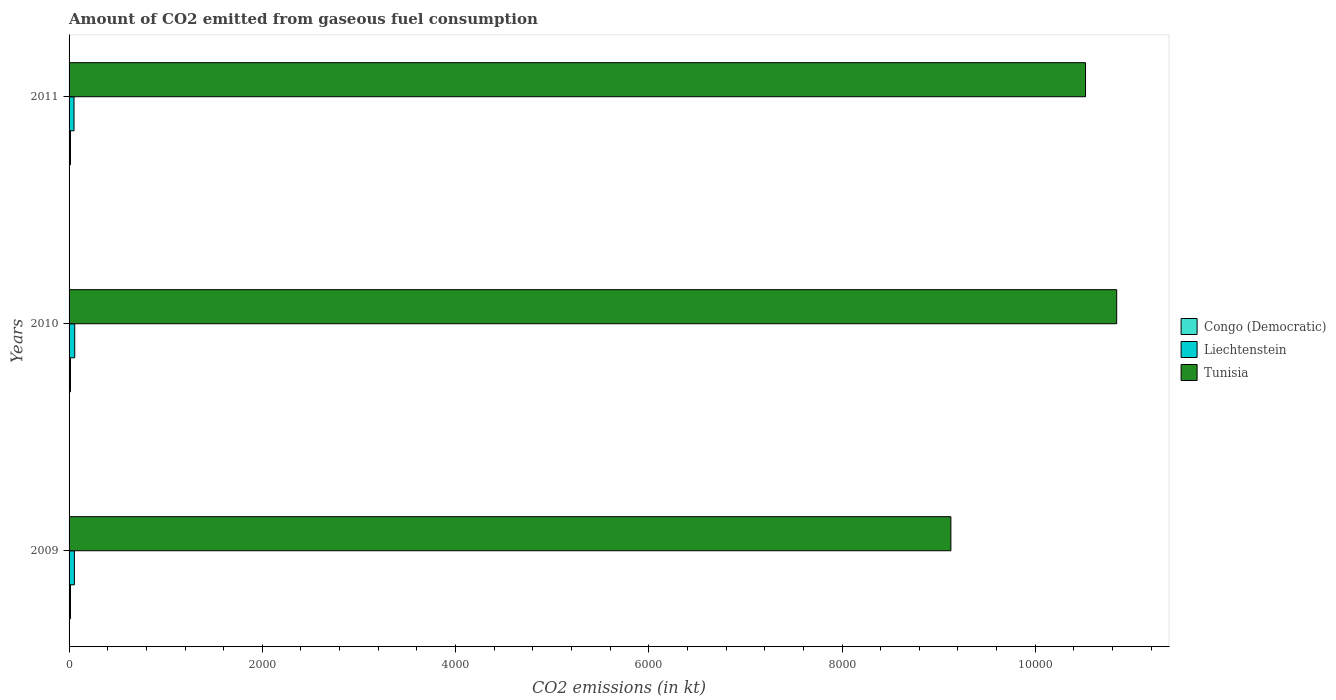Are the number of bars per tick equal to the number of legend labels?
Provide a succinct answer. Yes. How many bars are there on the 1st tick from the top?
Your answer should be compact. 3. What is the label of the 1st group of bars from the top?
Provide a succinct answer. 2011. What is the amount of CO2 emitted in Tunisia in 2010?
Keep it short and to the point. 1.08e+04. Across all years, what is the maximum amount of CO2 emitted in Tunisia?
Provide a short and direct response. 1.08e+04. Across all years, what is the minimum amount of CO2 emitted in Congo (Democratic)?
Make the answer very short. 14.67. In which year was the amount of CO2 emitted in Congo (Democratic) maximum?
Keep it short and to the point. 2009. In which year was the amount of CO2 emitted in Congo (Democratic) minimum?
Provide a succinct answer. 2009. What is the total amount of CO2 emitted in Liechtenstein in the graph?
Offer a very short reply. 165.01. What is the difference between the amount of CO2 emitted in Liechtenstein in 2009 and the amount of CO2 emitted in Congo (Democratic) in 2011?
Provide a short and direct response. 40.34. What is the average amount of CO2 emitted in Tunisia per year?
Your response must be concise. 1.02e+04. In the year 2010, what is the difference between the amount of CO2 emitted in Tunisia and amount of CO2 emitted in Liechtenstein?
Your response must be concise. 1.08e+04. What is the ratio of the amount of CO2 emitted in Liechtenstein in 2009 to that in 2011?
Keep it short and to the point. 1.07. Is the difference between the amount of CO2 emitted in Tunisia in 2009 and 2010 greater than the difference between the amount of CO2 emitted in Liechtenstein in 2009 and 2010?
Ensure brevity in your answer.  No. What is the difference between the highest and the second highest amount of CO2 emitted in Tunisia?
Your response must be concise. 322.7. Is the sum of the amount of CO2 emitted in Tunisia in 2009 and 2010 greater than the maximum amount of CO2 emitted in Congo (Democratic) across all years?
Offer a terse response. Yes. What does the 2nd bar from the top in 2010 represents?
Make the answer very short. Liechtenstein. What does the 1st bar from the bottom in 2010 represents?
Your answer should be compact. Congo (Democratic). Is it the case that in every year, the sum of the amount of CO2 emitted in Liechtenstein and amount of CO2 emitted in Congo (Democratic) is greater than the amount of CO2 emitted in Tunisia?
Ensure brevity in your answer.  No. How many bars are there?
Keep it short and to the point. 9. How many years are there in the graph?
Your answer should be very brief. 3. What is the difference between two consecutive major ticks on the X-axis?
Offer a terse response. 2000. Does the graph contain any zero values?
Make the answer very short. No. What is the title of the graph?
Give a very brief answer. Amount of CO2 emitted from gaseous fuel consumption. Does "Nicaragua" appear as one of the legend labels in the graph?
Make the answer very short. No. What is the label or title of the X-axis?
Provide a short and direct response. CO2 emissions (in kt). What is the label or title of the Y-axis?
Offer a very short reply. Years. What is the CO2 emissions (in kt) of Congo (Democratic) in 2009?
Offer a terse response. 14.67. What is the CO2 emissions (in kt) in Liechtenstein in 2009?
Your answer should be very brief. 55.01. What is the CO2 emissions (in kt) in Tunisia in 2009?
Give a very brief answer. 9127.16. What is the CO2 emissions (in kt) in Congo (Democratic) in 2010?
Ensure brevity in your answer.  14.67. What is the CO2 emissions (in kt) in Liechtenstein in 2010?
Your response must be concise. 58.67. What is the CO2 emissions (in kt) of Tunisia in 2010?
Make the answer very short. 1.08e+04. What is the CO2 emissions (in kt) of Congo (Democratic) in 2011?
Provide a short and direct response. 14.67. What is the CO2 emissions (in kt) of Liechtenstein in 2011?
Your answer should be compact. 51.34. What is the CO2 emissions (in kt) of Tunisia in 2011?
Your answer should be very brief. 1.05e+04. Across all years, what is the maximum CO2 emissions (in kt) in Congo (Democratic)?
Provide a short and direct response. 14.67. Across all years, what is the maximum CO2 emissions (in kt) in Liechtenstein?
Keep it short and to the point. 58.67. Across all years, what is the maximum CO2 emissions (in kt) in Tunisia?
Your answer should be very brief. 1.08e+04. Across all years, what is the minimum CO2 emissions (in kt) in Congo (Democratic)?
Provide a succinct answer. 14.67. Across all years, what is the minimum CO2 emissions (in kt) of Liechtenstein?
Your response must be concise. 51.34. Across all years, what is the minimum CO2 emissions (in kt) in Tunisia?
Your answer should be very brief. 9127.16. What is the total CO2 emissions (in kt) of Congo (Democratic) in the graph?
Your answer should be very brief. 44. What is the total CO2 emissions (in kt) of Liechtenstein in the graph?
Your response must be concise. 165.01. What is the total CO2 emissions (in kt) in Tunisia in the graph?
Offer a terse response. 3.05e+04. What is the difference between the CO2 emissions (in kt) in Congo (Democratic) in 2009 and that in 2010?
Offer a terse response. 0. What is the difference between the CO2 emissions (in kt) of Liechtenstein in 2009 and that in 2010?
Your response must be concise. -3.67. What is the difference between the CO2 emissions (in kt) in Tunisia in 2009 and that in 2010?
Your answer should be compact. -1716.16. What is the difference between the CO2 emissions (in kt) in Liechtenstein in 2009 and that in 2011?
Keep it short and to the point. 3.67. What is the difference between the CO2 emissions (in kt) in Tunisia in 2009 and that in 2011?
Provide a succinct answer. -1393.46. What is the difference between the CO2 emissions (in kt) of Liechtenstein in 2010 and that in 2011?
Your response must be concise. 7.33. What is the difference between the CO2 emissions (in kt) in Tunisia in 2010 and that in 2011?
Give a very brief answer. 322.7. What is the difference between the CO2 emissions (in kt) in Congo (Democratic) in 2009 and the CO2 emissions (in kt) in Liechtenstein in 2010?
Offer a terse response. -44. What is the difference between the CO2 emissions (in kt) in Congo (Democratic) in 2009 and the CO2 emissions (in kt) in Tunisia in 2010?
Your answer should be compact. -1.08e+04. What is the difference between the CO2 emissions (in kt) of Liechtenstein in 2009 and the CO2 emissions (in kt) of Tunisia in 2010?
Your answer should be very brief. -1.08e+04. What is the difference between the CO2 emissions (in kt) in Congo (Democratic) in 2009 and the CO2 emissions (in kt) in Liechtenstein in 2011?
Keep it short and to the point. -36.67. What is the difference between the CO2 emissions (in kt) of Congo (Democratic) in 2009 and the CO2 emissions (in kt) of Tunisia in 2011?
Provide a succinct answer. -1.05e+04. What is the difference between the CO2 emissions (in kt) of Liechtenstein in 2009 and the CO2 emissions (in kt) of Tunisia in 2011?
Give a very brief answer. -1.05e+04. What is the difference between the CO2 emissions (in kt) of Congo (Democratic) in 2010 and the CO2 emissions (in kt) of Liechtenstein in 2011?
Your answer should be compact. -36.67. What is the difference between the CO2 emissions (in kt) of Congo (Democratic) in 2010 and the CO2 emissions (in kt) of Tunisia in 2011?
Keep it short and to the point. -1.05e+04. What is the difference between the CO2 emissions (in kt) of Liechtenstein in 2010 and the CO2 emissions (in kt) of Tunisia in 2011?
Keep it short and to the point. -1.05e+04. What is the average CO2 emissions (in kt) of Congo (Democratic) per year?
Ensure brevity in your answer.  14.67. What is the average CO2 emissions (in kt) in Liechtenstein per year?
Give a very brief answer. 55.01. What is the average CO2 emissions (in kt) in Tunisia per year?
Keep it short and to the point. 1.02e+04. In the year 2009, what is the difference between the CO2 emissions (in kt) of Congo (Democratic) and CO2 emissions (in kt) of Liechtenstein?
Provide a succinct answer. -40.34. In the year 2009, what is the difference between the CO2 emissions (in kt) in Congo (Democratic) and CO2 emissions (in kt) in Tunisia?
Provide a succinct answer. -9112.5. In the year 2009, what is the difference between the CO2 emissions (in kt) in Liechtenstein and CO2 emissions (in kt) in Tunisia?
Give a very brief answer. -9072.16. In the year 2010, what is the difference between the CO2 emissions (in kt) in Congo (Democratic) and CO2 emissions (in kt) in Liechtenstein?
Keep it short and to the point. -44. In the year 2010, what is the difference between the CO2 emissions (in kt) of Congo (Democratic) and CO2 emissions (in kt) of Tunisia?
Provide a succinct answer. -1.08e+04. In the year 2010, what is the difference between the CO2 emissions (in kt) in Liechtenstein and CO2 emissions (in kt) in Tunisia?
Offer a very short reply. -1.08e+04. In the year 2011, what is the difference between the CO2 emissions (in kt) in Congo (Democratic) and CO2 emissions (in kt) in Liechtenstein?
Keep it short and to the point. -36.67. In the year 2011, what is the difference between the CO2 emissions (in kt) of Congo (Democratic) and CO2 emissions (in kt) of Tunisia?
Your answer should be very brief. -1.05e+04. In the year 2011, what is the difference between the CO2 emissions (in kt) of Liechtenstein and CO2 emissions (in kt) of Tunisia?
Provide a short and direct response. -1.05e+04. What is the ratio of the CO2 emissions (in kt) in Tunisia in 2009 to that in 2010?
Provide a succinct answer. 0.84. What is the ratio of the CO2 emissions (in kt) of Liechtenstein in 2009 to that in 2011?
Your answer should be very brief. 1.07. What is the ratio of the CO2 emissions (in kt) in Tunisia in 2009 to that in 2011?
Your answer should be compact. 0.87. What is the ratio of the CO2 emissions (in kt) of Congo (Democratic) in 2010 to that in 2011?
Keep it short and to the point. 1. What is the ratio of the CO2 emissions (in kt) of Liechtenstein in 2010 to that in 2011?
Provide a succinct answer. 1.14. What is the ratio of the CO2 emissions (in kt) of Tunisia in 2010 to that in 2011?
Keep it short and to the point. 1.03. What is the difference between the highest and the second highest CO2 emissions (in kt) of Liechtenstein?
Keep it short and to the point. 3.67. What is the difference between the highest and the second highest CO2 emissions (in kt) in Tunisia?
Your answer should be very brief. 322.7. What is the difference between the highest and the lowest CO2 emissions (in kt) of Congo (Democratic)?
Your answer should be very brief. 0. What is the difference between the highest and the lowest CO2 emissions (in kt) in Liechtenstein?
Your answer should be compact. 7.33. What is the difference between the highest and the lowest CO2 emissions (in kt) of Tunisia?
Ensure brevity in your answer.  1716.16. 